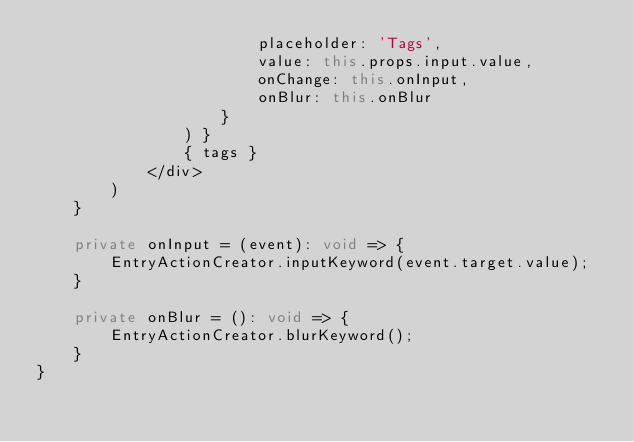<code> <loc_0><loc_0><loc_500><loc_500><_TypeScript_>                        placeholder: 'Tags', 
                        value: this.props.input.value,
                        onChange: this.onInput,
                        onBlur: this.onBlur
                    }
                ) }
                { tags }
            </div>
        )
    }

    private onInput = (event): void => {
        EntryActionCreator.inputKeyword(event.target.value);
    }

    private onBlur = (): void => {
        EntryActionCreator.blurKeyword();
    }
}
</code> 